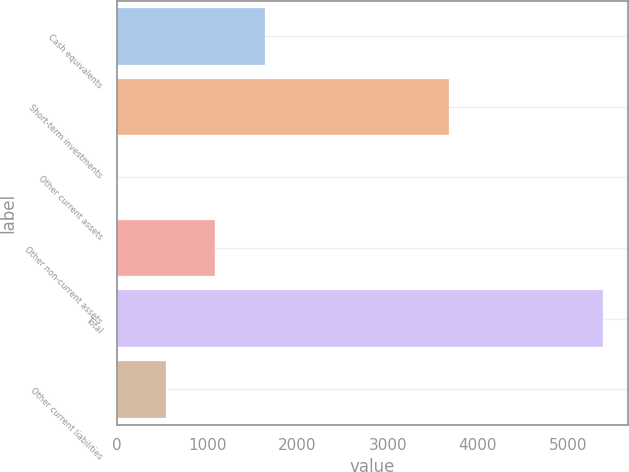Convert chart. <chart><loc_0><loc_0><loc_500><loc_500><bar_chart><fcel>Cash equivalents<fcel>Short-term investments<fcel>Other current assets<fcel>Other non-current assets<fcel>Total<fcel>Other current liabilities<nl><fcel>1642.4<fcel>3675.5<fcel>2.8<fcel>1080.12<fcel>5389.4<fcel>541.46<nl></chart> 